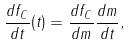<formula> <loc_0><loc_0><loc_500><loc_500>\frac { d f _ { C } } { d t } ( t ) = \frac { d f _ { C } } { d m } \frac { d m } { d t } ,</formula> 